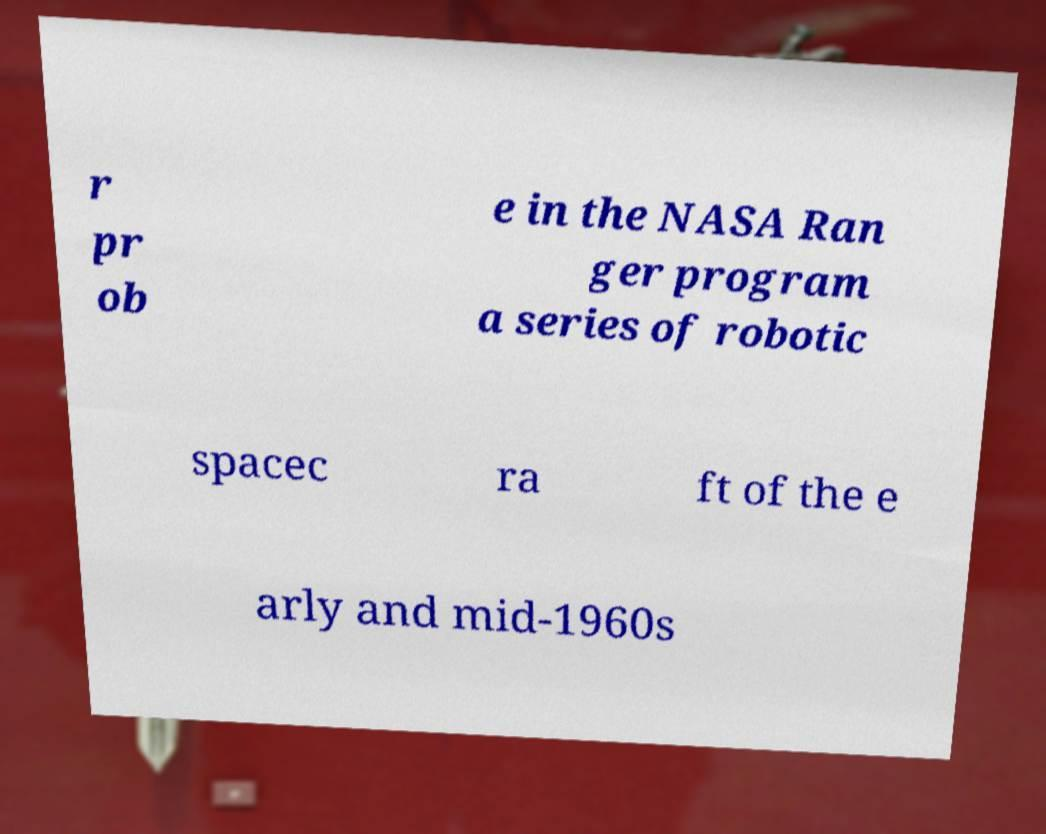There's text embedded in this image that I need extracted. Can you transcribe it verbatim? r pr ob e in the NASA Ran ger program a series of robotic spacec ra ft of the e arly and mid-1960s 